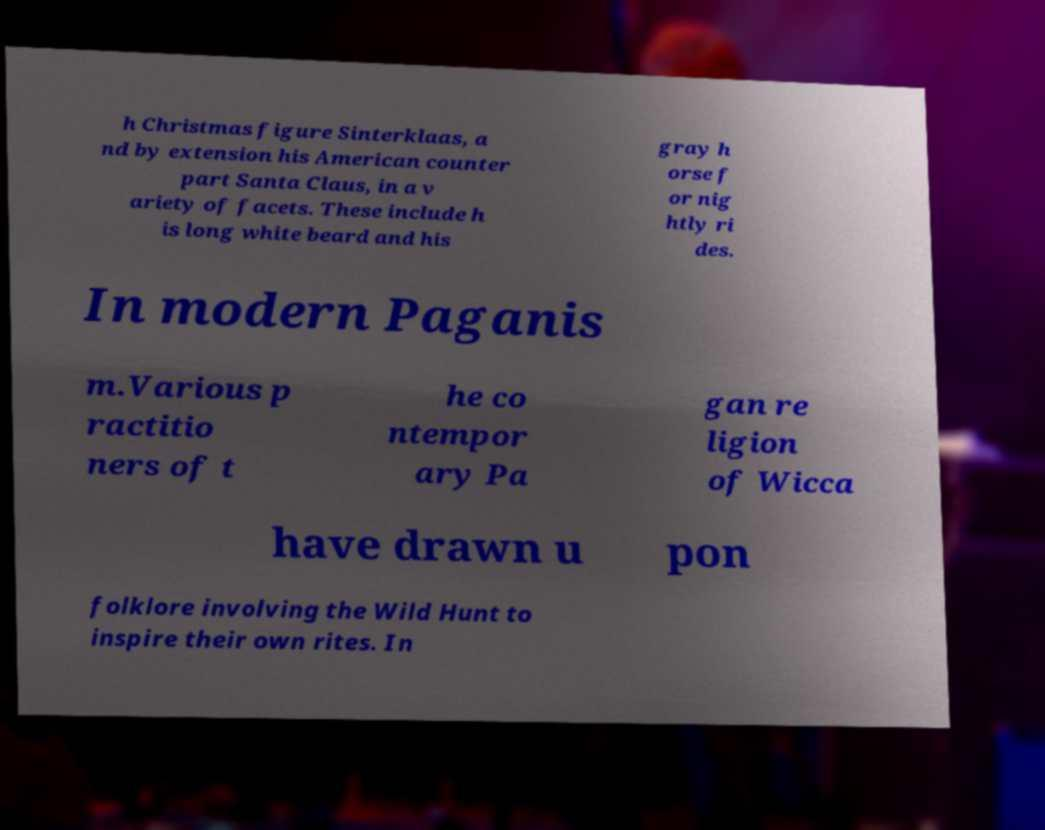There's text embedded in this image that I need extracted. Can you transcribe it verbatim? h Christmas figure Sinterklaas, a nd by extension his American counter part Santa Claus, in a v ariety of facets. These include h is long white beard and his gray h orse f or nig htly ri des. In modern Paganis m.Various p ractitio ners of t he co ntempor ary Pa gan re ligion of Wicca have drawn u pon folklore involving the Wild Hunt to inspire their own rites. In 